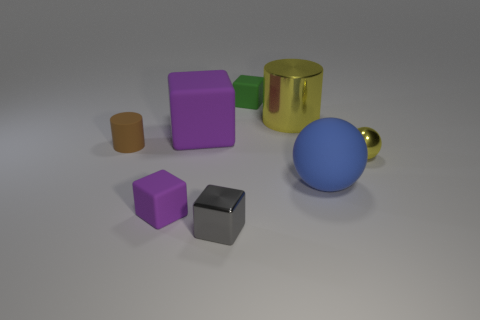Are any brown rubber objects visible?
Your response must be concise. Yes. What number of objects are either tiny metallic balls that are to the right of the shiny cube or brown cylinders?
Make the answer very short. 2. There is a tiny metallic ball; does it have the same color as the small metal object in front of the big blue thing?
Provide a short and direct response. No. Is there a yellow metal object of the same size as the green rubber block?
Provide a succinct answer. Yes. What material is the yellow thing that is in front of the purple thing on the right side of the tiny purple rubber block?
Ensure brevity in your answer.  Metal. How many small rubber cylinders have the same color as the matte ball?
Offer a very short reply. 0. There is a large yellow object that is made of the same material as the gray cube; what is its shape?
Your answer should be compact. Cylinder. There is a cube on the right side of the small gray object; what size is it?
Provide a succinct answer. Small. Are there the same number of gray metal blocks right of the shiny ball and large purple cubes to the left of the large blue matte thing?
Make the answer very short. No. What color is the tiny rubber cube that is behind the purple cube that is in front of the big matte thing that is to the left of the small metallic block?
Provide a succinct answer. Green. 